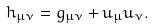<formula> <loc_0><loc_0><loc_500><loc_500>h _ { \mu \nu } = g _ { \mu \nu } + u _ { \mu } u _ { \nu } .</formula> 